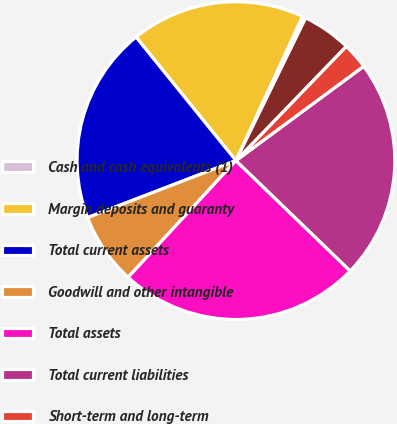<chart> <loc_0><loc_0><loc_500><loc_500><pie_chart><fcel>Cash and cash equivalents (1)<fcel>Margin deposits and guaranty<fcel>Total current assets<fcel>Goodwill and other intangible<fcel>Total assets<fcel>Total current liabilities<fcel>Short-term and long-term<fcel>Equity (1)<nl><fcel>0.35%<fcel>17.71%<fcel>20.02%<fcel>7.29%<fcel>24.65%<fcel>22.34%<fcel>2.66%<fcel>4.98%<nl></chart> 